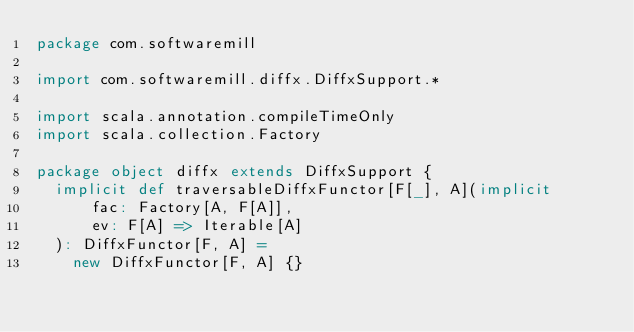<code> <loc_0><loc_0><loc_500><loc_500><_Scala_>package com.softwaremill

import com.softwaremill.diffx.DiffxSupport.*

import scala.annotation.compileTimeOnly
import scala.collection.Factory

package object diffx extends DiffxSupport {
  implicit def traversableDiffxFunctor[F[_], A](implicit
      fac: Factory[A, F[A]],
      ev: F[A] => Iterable[A]
  ): DiffxFunctor[F, A] =
    new DiffxFunctor[F, A] {}
</code> 